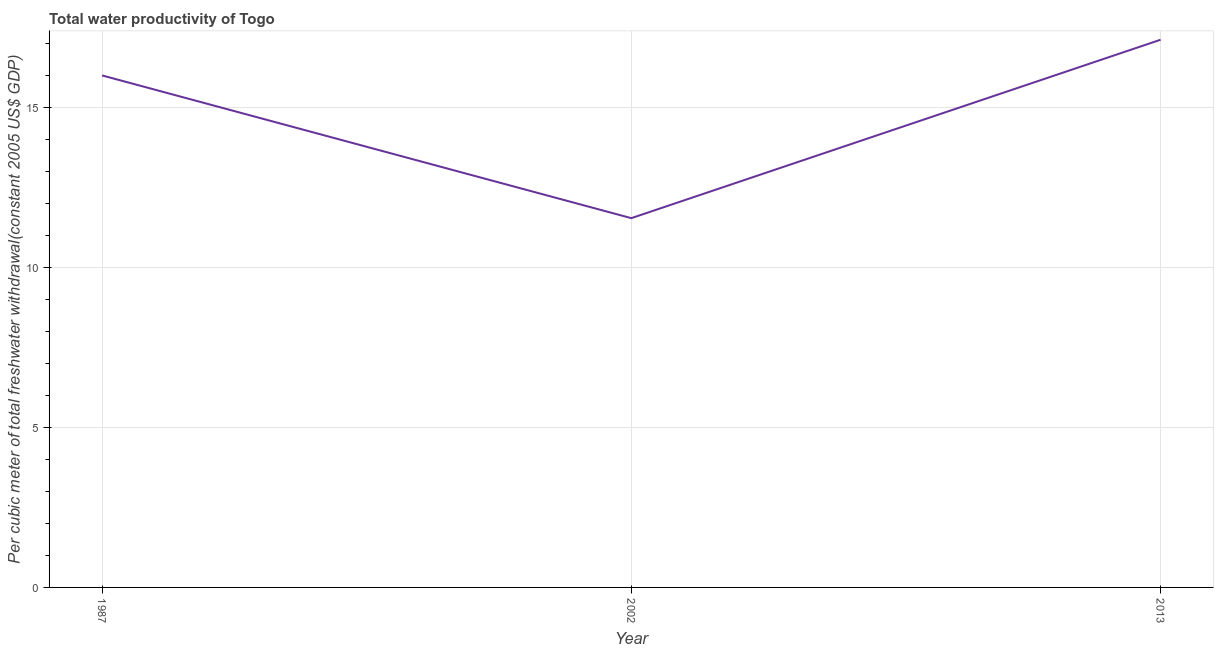What is the total water productivity in 2013?
Your answer should be very brief. 17.12. Across all years, what is the maximum total water productivity?
Your answer should be compact. 17.12. Across all years, what is the minimum total water productivity?
Offer a terse response. 11.54. In which year was the total water productivity maximum?
Keep it short and to the point. 2013. What is the sum of the total water productivity?
Make the answer very short. 44.66. What is the difference between the total water productivity in 2002 and 2013?
Offer a very short reply. -5.58. What is the average total water productivity per year?
Offer a terse response. 14.89. What is the median total water productivity?
Your answer should be very brief. 16. In how many years, is the total water productivity greater than 15 US$?
Your response must be concise. 2. Do a majority of the years between 2013 and 2002 (inclusive) have total water productivity greater than 10 US$?
Provide a succinct answer. No. What is the ratio of the total water productivity in 1987 to that in 2002?
Make the answer very short. 1.39. Is the total water productivity in 1987 less than that in 2013?
Offer a terse response. Yes. Is the difference between the total water productivity in 2002 and 2013 greater than the difference between any two years?
Your answer should be very brief. Yes. What is the difference between the highest and the second highest total water productivity?
Provide a short and direct response. 1.12. What is the difference between the highest and the lowest total water productivity?
Keep it short and to the point. 5.58. What is the difference between two consecutive major ticks on the Y-axis?
Give a very brief answer. 5. Are the values on the major ticks of Y-axis written in scientific E-notation?
Offer a very short reply. No. Does the graph contain grids?
Your answer should be compact. Yes. What is the title of the graph?
Ensure brevity in your answer.  Total water productivity of Togo. What is the label or title of the X-axis?
Offer a terse response. Year. What is the label or title of the Y-axis?
Provide a succinct answer. Per cubic meter of total freshwater withdrawal(constant 2005 US$ GDP). What is the Per cubic meter of total freshwater withdrawal(constant 2005 US$ GDP) of 1987?
Ensure brevity in your answer.  16. What is the Per cubic meter of total freshwater withdrawal(constant 2005 US$ GDP) of 2002?
Your answer should be very brief. 11.54. What is the Per cubic meter of total freshwater withdrawal(constant 2005 US$ GDP) of 2013?
Ensure brevity in your answer.  17.12. What is the difference between the Per cubic meter of total freshwater withdrawal(constant 2005 US$ GDP) in 1987 and 2002?
Offer a very short reply. 4.46. What is the difference between the Per cubic meter of total freshwater withdrawal(constant 2005 US$ GDP) in 1987 and 2013?
Offer a terse response. -1.12. What is the difference between the Per cubic meter of total freshwater withdrawal(constant 2005 US$ GDP) in 2002 and 2013?
Give a very brief answer. -5.58. What is the ratio of the Per cubic meter of total freshwater withdrawal(constant 2005 US$ GDP) in 1987 to that in 2002?
Provide a short and direct response. 1.39. What is the ratio of the Per cubic meter of total freshwater withdrawal(constant 2005 US$ GDP) in 1987 to that in 2013?
Ensure brevity in your answer.  0.94. What is the ratio of the Per cubic meter of total freshwater withdrawal(constant 2005 US$ GDP) in 2002 to that in 2013?
Offer a very short reply. 0.67. 